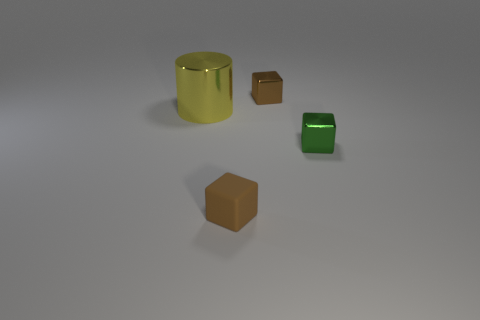How many things are either metal blocks that are behind the yellow cylinder or large red matte cylinders?
Offer a very short reply. 1. Are there any other brown objects that have the same shape as the brown matte object?
Ensure brevity in your answer.  Yes. What shape is the green thing that is the same size as the matte block?
Provide a succinct answer. Cube. There is a metal thing right of the brown block behind the tiny green cube in front of the big yellow metal cylinder; what shape is it?
Your answer should be compact. Cube. Is the shape of the brown metallic object the same as the tiny shiny object in front of the large cylinder?
Your response must be concise. Yes. What number of large objects are cyan balls or yellow metal cylinders?
Your response must be concise. 1. Are there any other matte objects of the same size as the yellow thing?
Provide a short and direct response. No. The small object to the left of the small brown object right of the brown block in front of the green block is what color?
Ensure brevity in your answer.  Brown. Does the large thing have the same material as the brown block that is in front of the yellow metal cylinder?
Make the answer very short. No. What is the size of the brown metal thing that is the same shape as the brown rubber thing?
Ensure brevity in your answer.  Small. 